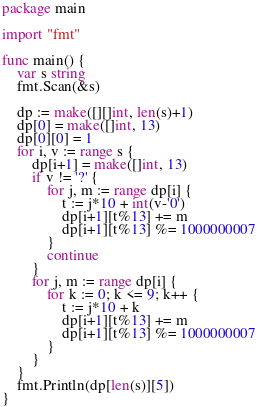Convert code to text. <code><loc_0><loc_0><loc_500><loc_500><_Go_>package main

import "fmt"

func main() {
	var s string
	fmt.Scan(&s)

	dp := make([][]int, len(s)+1)
	dp[0] = make([]int, 13)
	dp[0][0] = 1
	for i, v := range s {
		dp[i+1] = make([]int, 13)
		if v != '?' {
			for j, m := range dp[i] {
				t := j*10 + int(v-'0')
				dp[i+1][t%13] += m
				dp[i+1][t%13] %= 1000000007
			}
			continue
		}
		for j, m := range dp[i] {
			for k := 0; k <= 9; k++ {
				t := j*10 + k
				dp[i+1][t%13] += m
				dp[i+1][t%13] %= 1000000007
			}
		}
	}
	fmt.Println(dp[len(s)][5])
}
</code> 